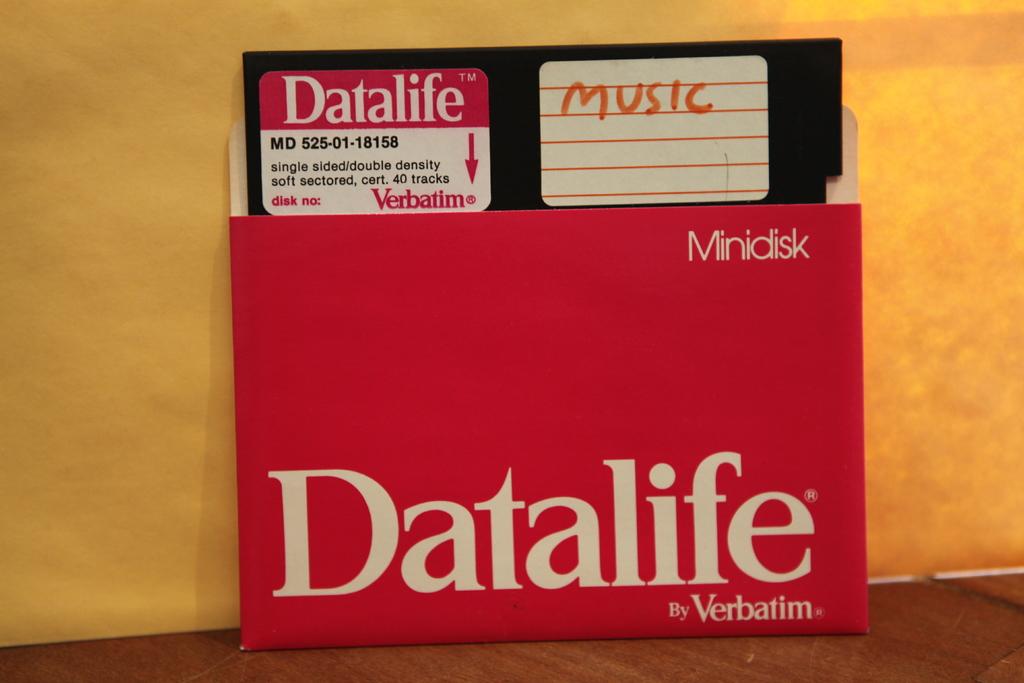What brand of disk is this?
Your answer should be compact. Datalife. 